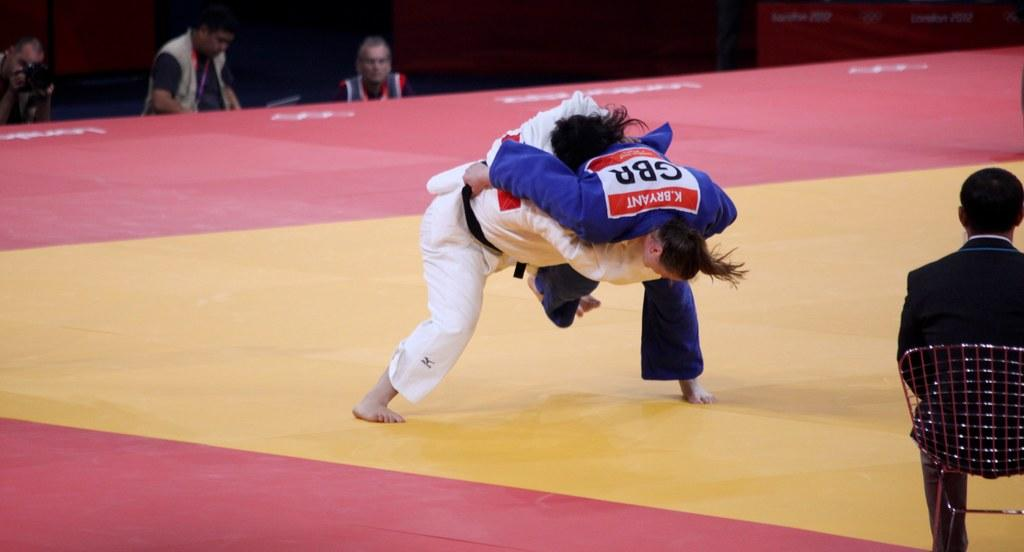<image>
Give a short and clear explanation of the subsequent image. K Bryant of the GB Judo team wrestles his opponent as judges look on. 